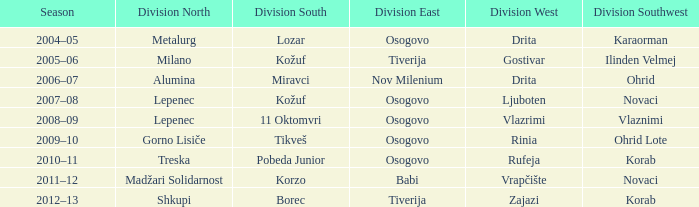Who won Division Southwest when the winner of Division North was Lepenec and Division South was won by 11 Oktomvri? Vlaznimi. 